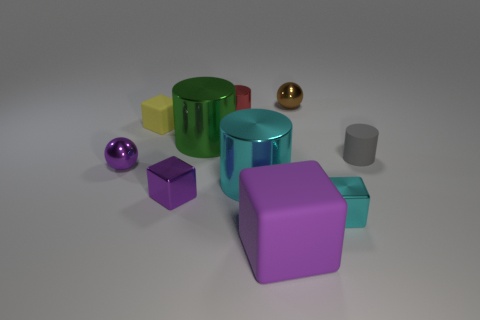Subtract all large cyan metal cylinders. How many cylinders are left? 3 Subtract all brown spheres. How many spheres are left? 1 Subtract all blocks. How many objects are left? 6 Subtract all green blocks. How many brown balls are left? 1 Subtract all yellow balls. Subtract all purple cylinders. How many balls are left? 2 Subtract all yellow blocks. Subtract all cyan cubes. How many objects are left? 8 Add 3 yellow cubes. How many yellow cubes are left? 4 Add 4 small green cylinders. How many small green cylinders exist? 4 Subtract 1 cyan cylinders. How many objects are left? 9 Subtract 1 cylinders. How many cylinders are left? 3 